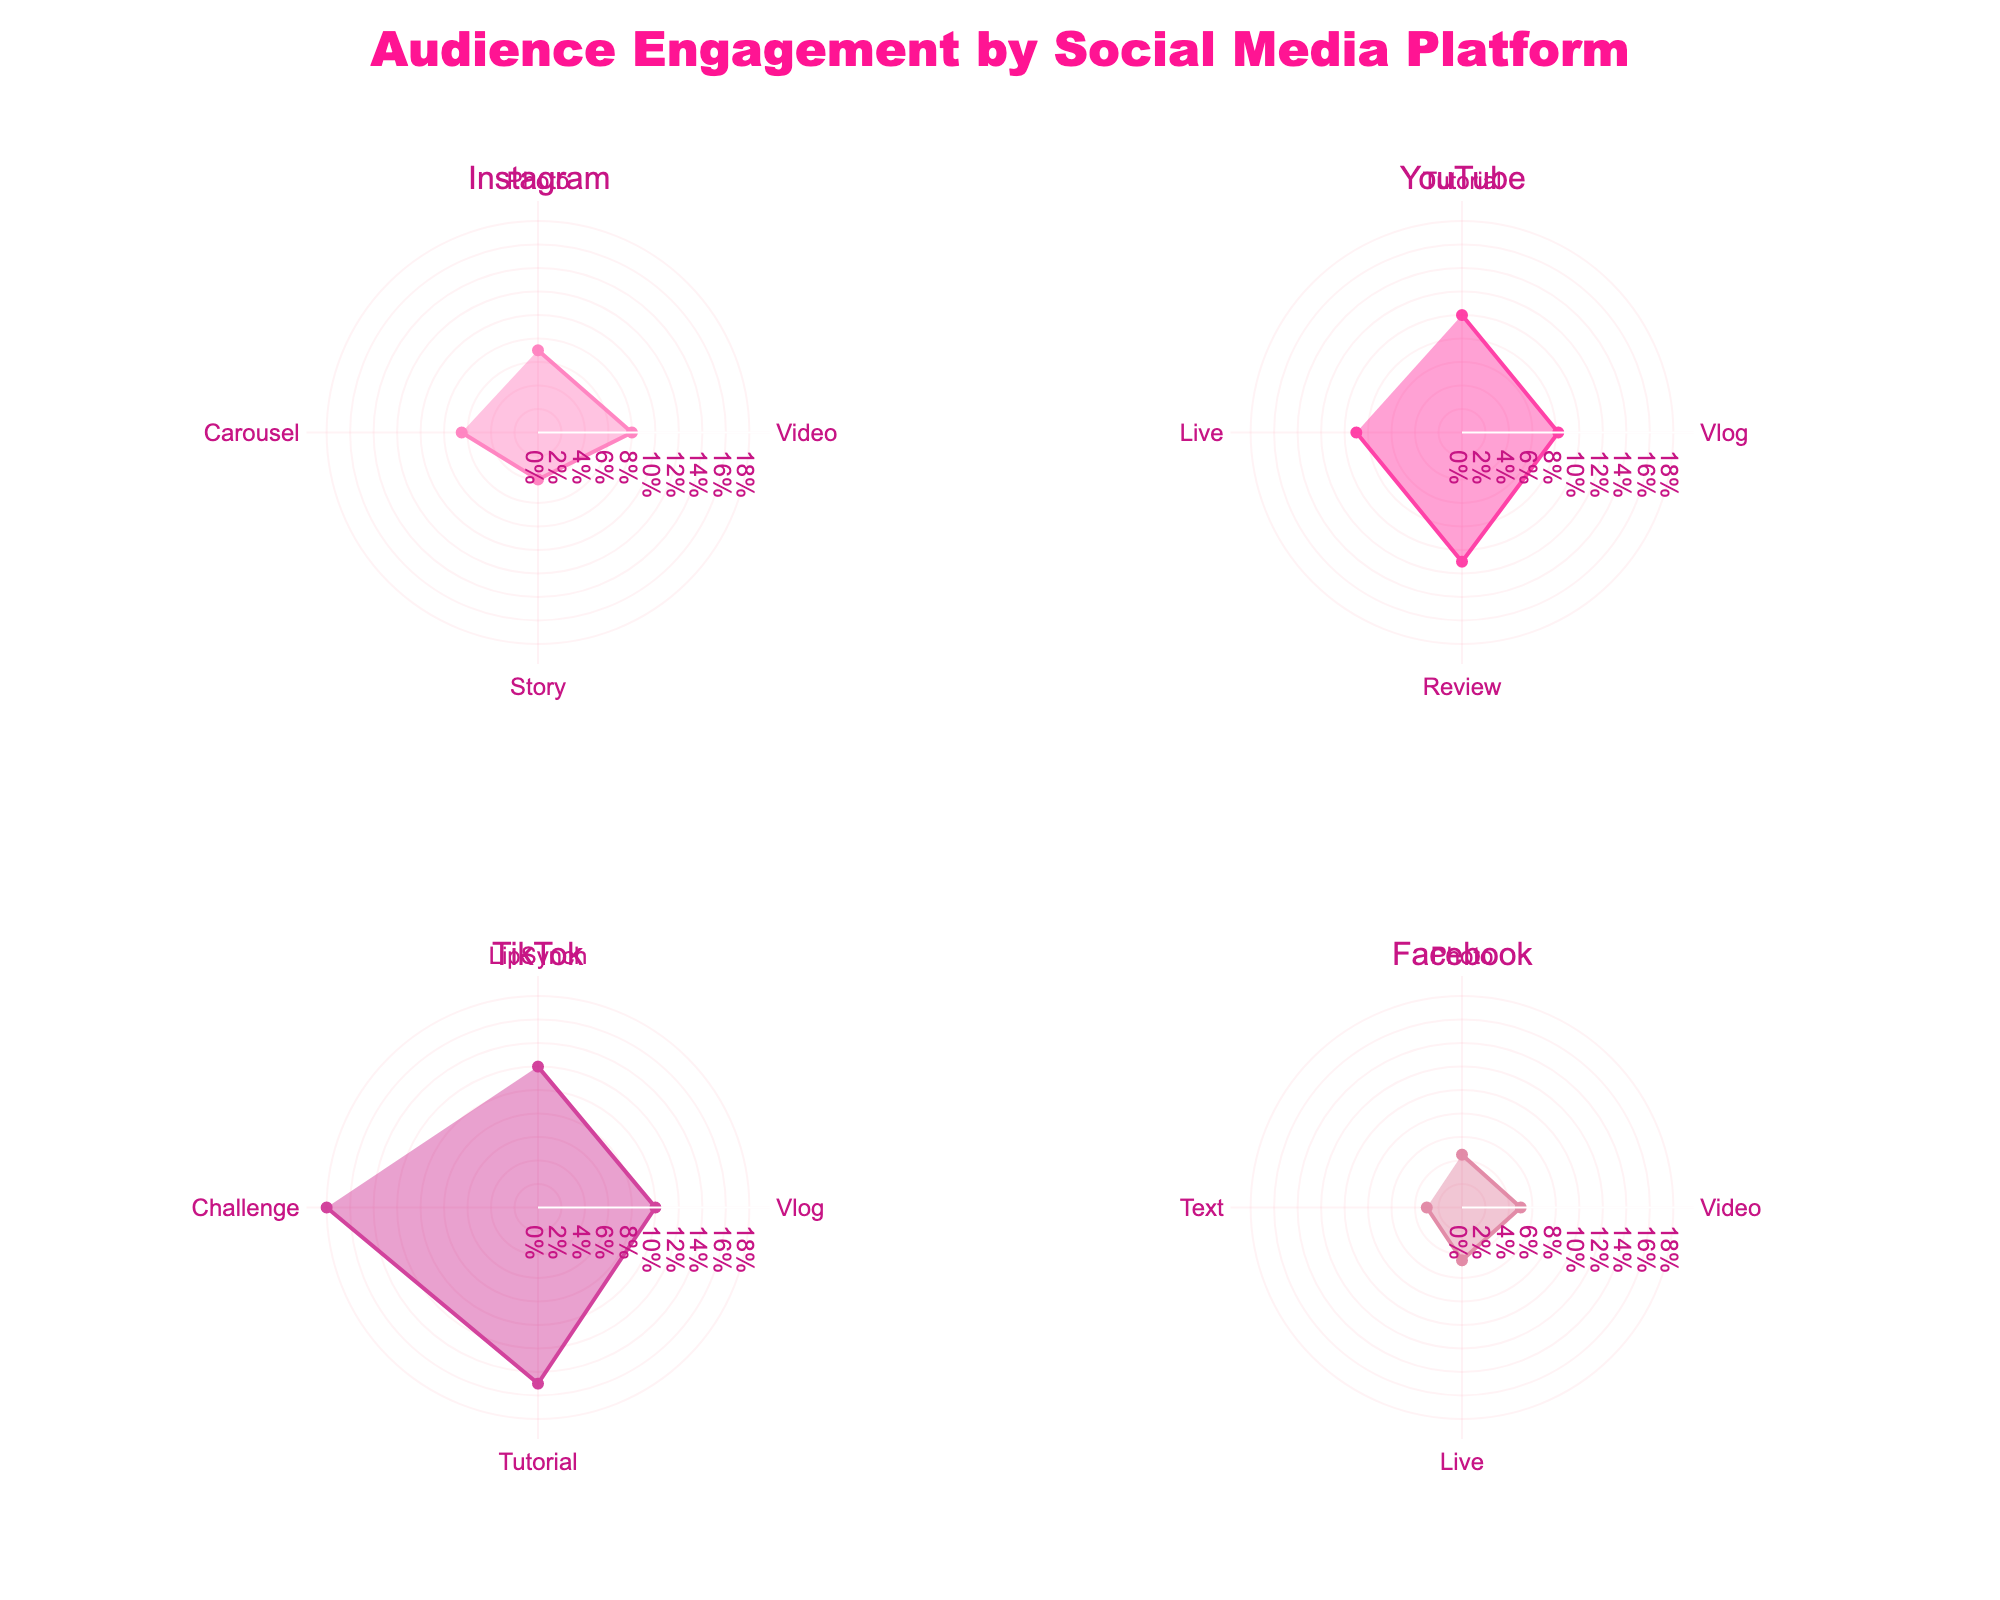What is the title of the figure? The title of the figure is usually located at the top center. In this case, the title is "Audience Engagement by Social Media Platform".
Answer: Audience Engagement by Social Media Platform Which social media platform has the highest engagement rate for any post type? Looking at the figures, we identify the highest points or rates. TikTok shows the highest engagement rate at 18% for Challenge posts.
Answer: TikTok What is the engagement rate of YouTube Tutorials compared to TikTok Vlogs? The rates can be read directly from the charts. YouTube Tutorials have a rate of 10%, and TikTok Vlogs have a rate of 10%. Comparing them, they are equal.
Answer: Equal Which post type on Instagram has the highest engagement rate? By examining the Instagram subplot, the highest point representing engagement shows that Video posts have the highest rate at 8%.
Answer: Video Summarize the engagement rate ranges across all platforms. Each subplot's radial axis range starts at 0%, going to approximately 20%, which is consistent across the four subplots.
Answer: 0% to 20% Which social media platform has the lowest average engagement rate across all post types? Calculating the average for each platform: 
Instagram: (7+8+4+6.5)/4 = 6.375%, 
YouTube: (10+8.2+11+9)/4 = 9.55%, 
TikTok: (12+10+15+18)/4 = 13.75%, 
Facebook: (4.5+5+4.5+3)/4 = 4.25%. 
Instagram has an average engagement rate of 6.375%. The lowest is Facebook at 4.25%.
Answer: Facebook Compare the engagement rates of Facebook Photo and Instagram Photo posts. Observing both subplots, Instagram Photo posts have an engagement rate of 7%, while Facebook Photo posts have a rate of 4.5%.
Answer: Instagram has higher engagement for Photo posts Which post type is shared across all platforms, and how does its engagement rate vary? By looking at the post types in each subplot, Video posts are common across all platforms. The engagement rates are: Instagram (8%), YouTube (Video/8.2%), TikTok (Video/Vlog/10%), Facebook (5%).
Answer: Instagram (8%), YouTube (8.2%), TikTok (10%), Facebook (5%) Determine the difference in engagement rates between TikTok Challenges and Facebook Videos. From the respective subplots, TikTok Challenge posts have an engagement rate of 18%, and Facebook Video posts have 5%. The difference is 18% - 5% = 13%.
Answer: 13% 